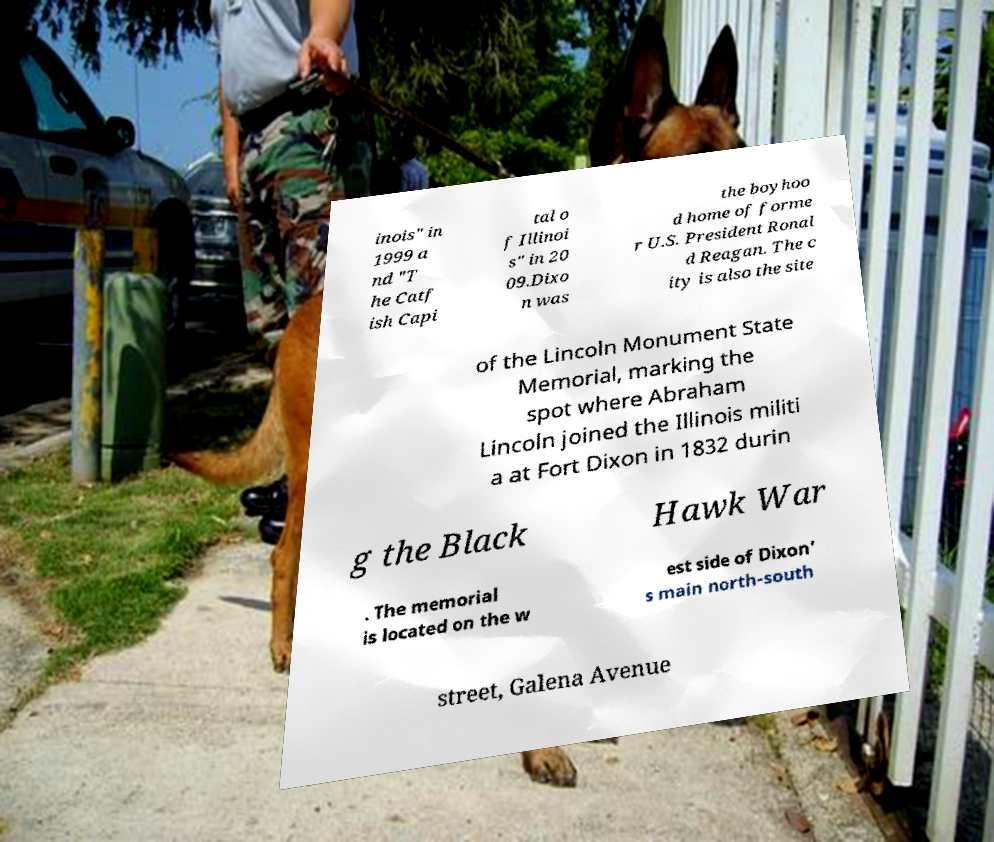What messages or text are displayed in this image? I need them in a readable, typed format. inois" in 1999 a nd "T he Catf ish Capi tal o f Illinoi s" in 20 09.Dixo n was the boyhoo d home of forme r U.S. President Ronal d Reagan. The c ity is also the site of the Lincoln Monument State Memorial, marking the spot where Abraham Lincoln joined the Illinois militi a at Fort Dixon in 1832 durin g the Black Hawk War . The memorial is located on the w est side of Dixon' s main north-south street, Galena Avenue 